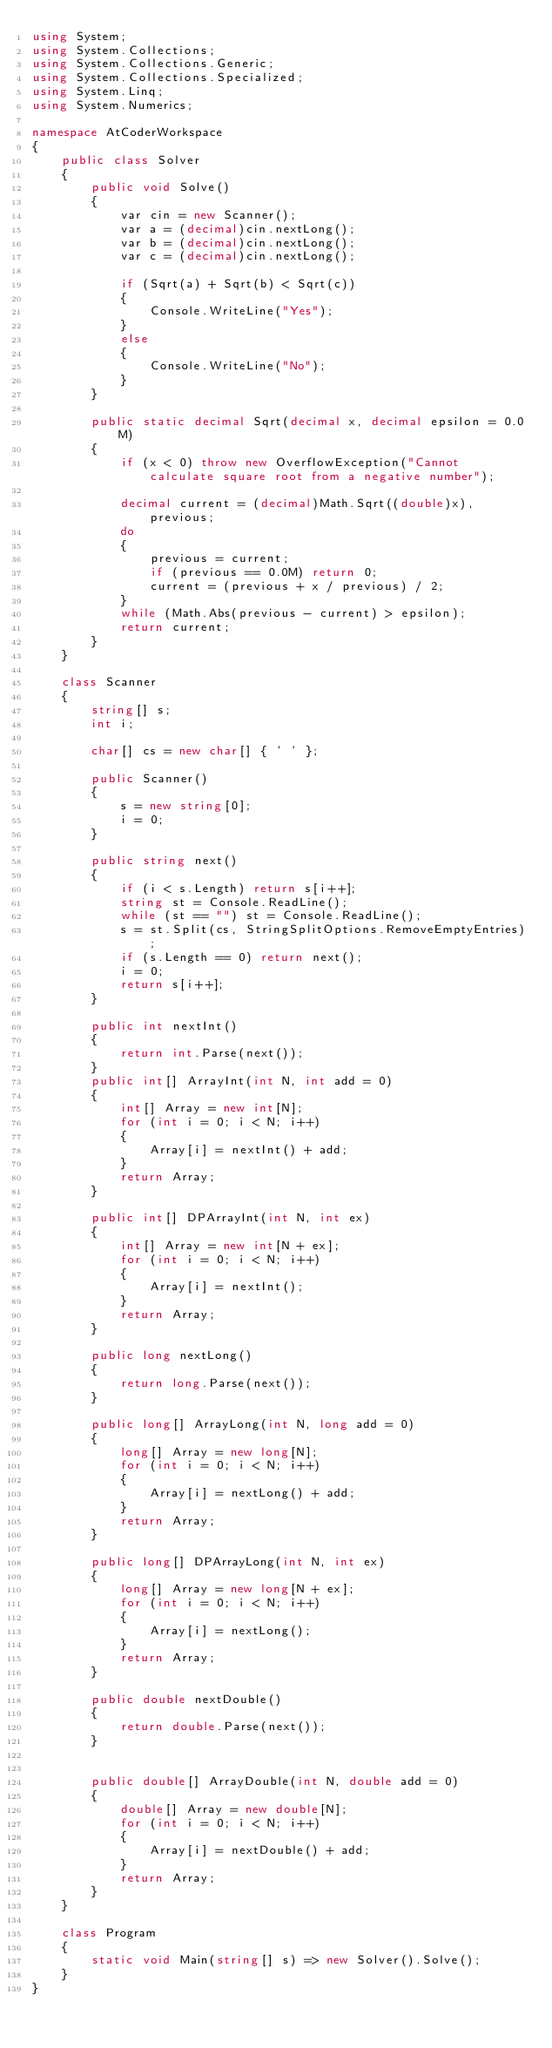<code> <loc_0><loc_0><loc_500><loc_500><_C#_>using System;
using System.Collections;
using System.Collections.Generic;
using System.Collections.Specialized;
using System.Linq;
using System.Numerics;

namespace AtCoderWorkspace
{
    public class Solver
    {
        public void Solve()
        {
            var cin = new Scanner();
            var a = (decimal)cin.nextLong();
            var b = (decimal)cin.nextLong();
            var c = (decimal)cin.nextLong();

            if (Sqrt(a) + Sqrt(b) < Sqrt(c))
            {
                Console.WriteLine("Yes");
            }
            else
            {
                Console.WriteLine("No");
            }            
        }

        public static decimal Sqrt(decimal x, decimal epsilon = 0.0M)
        {
            if (x < 0) throw new OverflowException("Cannot calculate square root from a negative number");

            decimal current = (decimal)Math.Sqrt((double)x), previous;
            do
            {
                previous = current;
                if (previous == 0.0M) return 0;
                current = (previous + x / previous) / 2;
            }
            while (Math.Abs(previous - current) > epsilon);
            return current;
        }
    }

    class Scanner
    {
        string[] s;
        int i;

        char[] cs = new char[] { ' ' };

        public Scanner()
        {
            s = new string[0];
            i = 0;
        }

        public string next()
        {
            if (i < s.Length) return s[i++];
            string st = Console.ReadLine();
            while (st == "") st = Console.ReadLine();
            s = st.Split(cs, StringSplitOptions.RemoveEmptyEntries);
            if (s.Length == 0) return next();
            i = 0;
            return s[i++];
        }

        public int nextInt()
        {
            return int.Parse(next());
        }
        public int[] ArrayInt(int N, int add = 0)
        {
            int[] Array = new int[N];
            for (int i = 0; i < N; i++)
            {
                Array[i] = nextInt() + add;
            }
            return Array;
        }

        public int[] DPArrayInt(int N, int ex)
        {
            int[] Array = new int[N + ex];
            for (int i = 0; i < N; i++)
            {
                Array[i] = nextInt();
            }
            return Array;
        }

        public long nextLong()
        {
            return long.Parse(next());
        }

        public long[] ArrayLong(int N, long add = 0)
        {
            long[] Array = new long[N];
            for (int i = 0; i < N; i++)
            {
                Array[i] = nextLong() + add;
            }
            return Array;
        }

        public long[] DPArrayLong(int N, int ex)
        {
            long[] Array = new long[N + ex];
            for (int i = 0; i < N; i++)
            {
                Array[i] = nextLong();
            }
            return Array;
        }

        public double nextDouble()
        {
            return double.Parse(next());
        }


        public double[] ArrayDouble(int N, double add = 0)
        {
            double[] Array = new double[N];
            for (int i = 0; i < N; i++)
            {
                Array[i] = nextDouble() + add;
            }
            return Array;
        }
    }

    class Program
    {
        static void Main(string[] s) => new Solver().Solve();
    }
}
</code> 